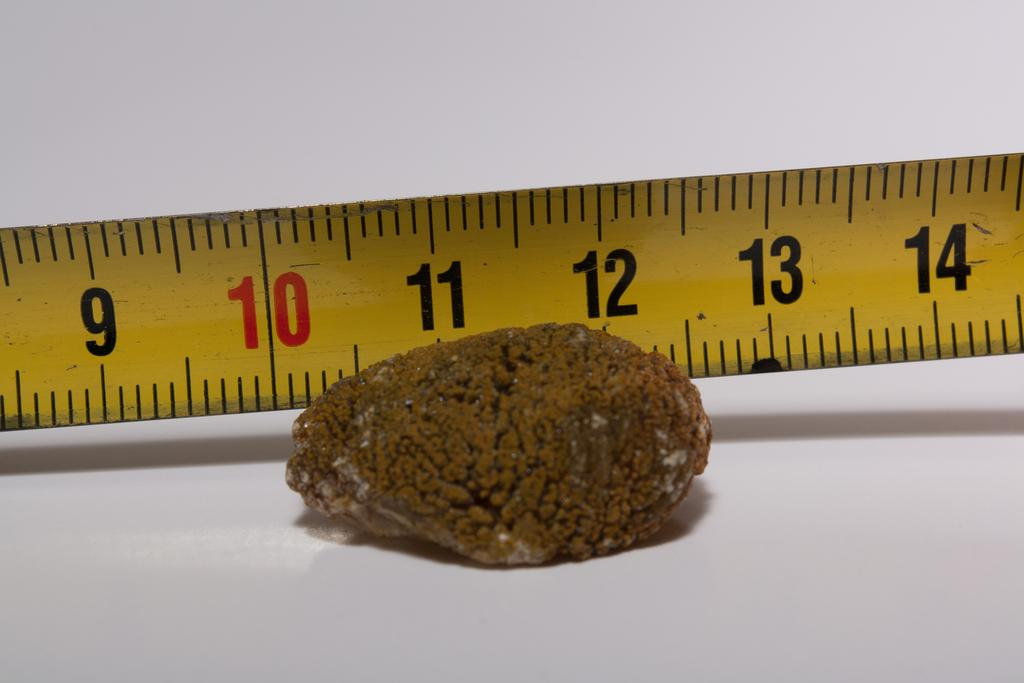<image>
Offer a succinct explanation of the picture presented. Yellow ruler with a red number 10 on it measuring a rock. 